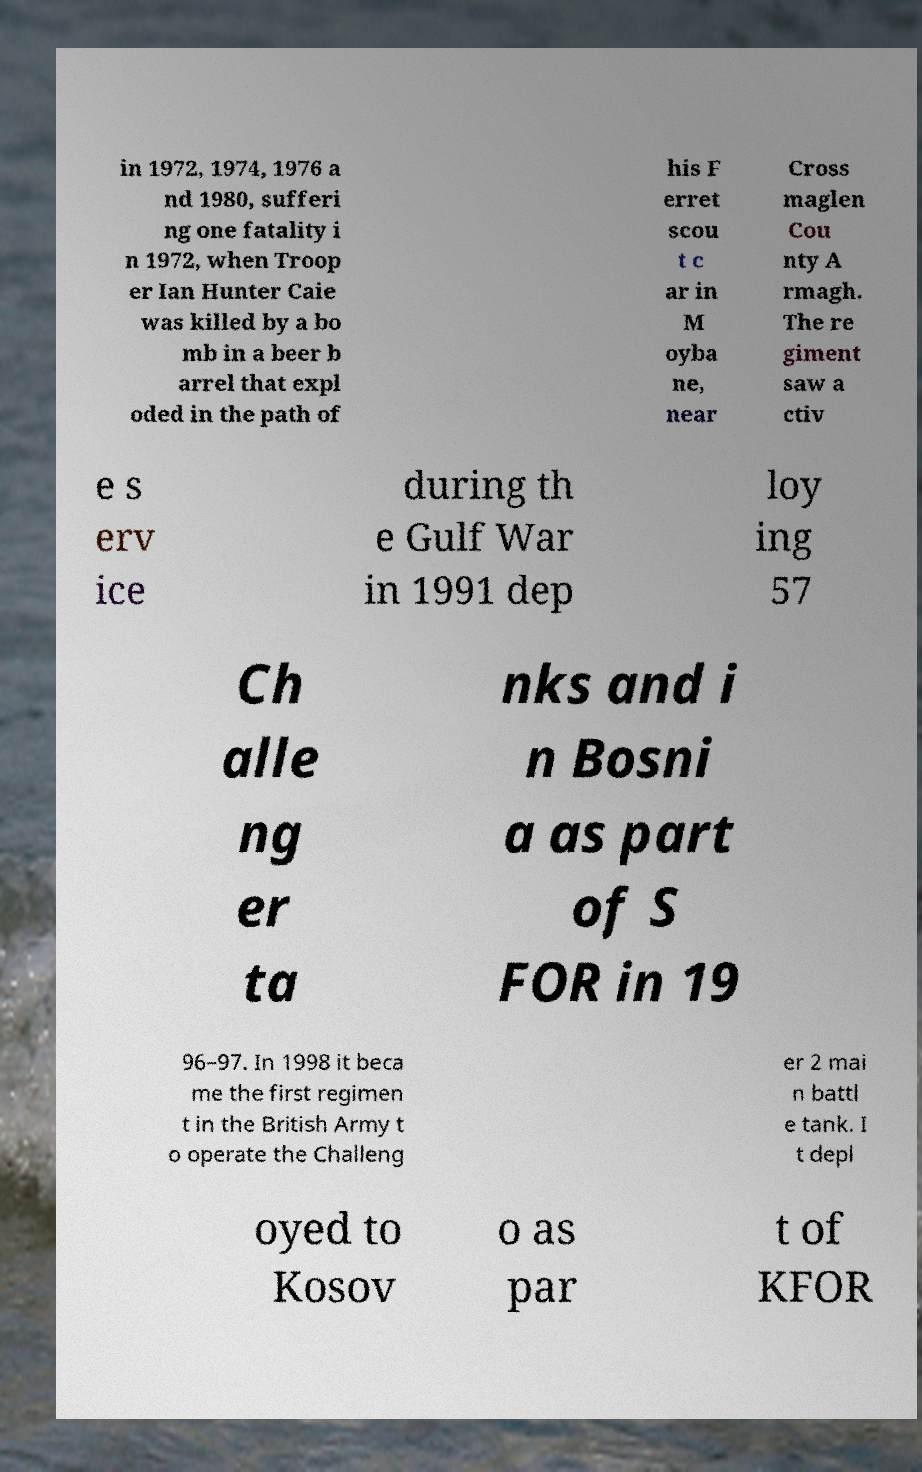For documentation purposes, I need the text within this image transcribed. Could you provide that? in 1972, 1974, 1976 a nd 1980, sufferi ng one fatality i n 1972, when Troop er Ian Hunter Caie was killed by a bo mb in a beer b arrel that expl oded in the path of his F erret scou t c ar in M oyba ne, near Cross maglen Cou nty A rmagh. The re giment saw a ctiv e s erv ice during th e Gulf War in 1991 dep loy ing 57 Ch alle ng er ta nks and i n Bosni a as part of S FOR in 19 96–97. In 1998 it beca me the first regimen t in the British Army t o operate the Challeng er 2 mai n battl e tank. I t depl oyed to Kosov o as par t of KFOR 